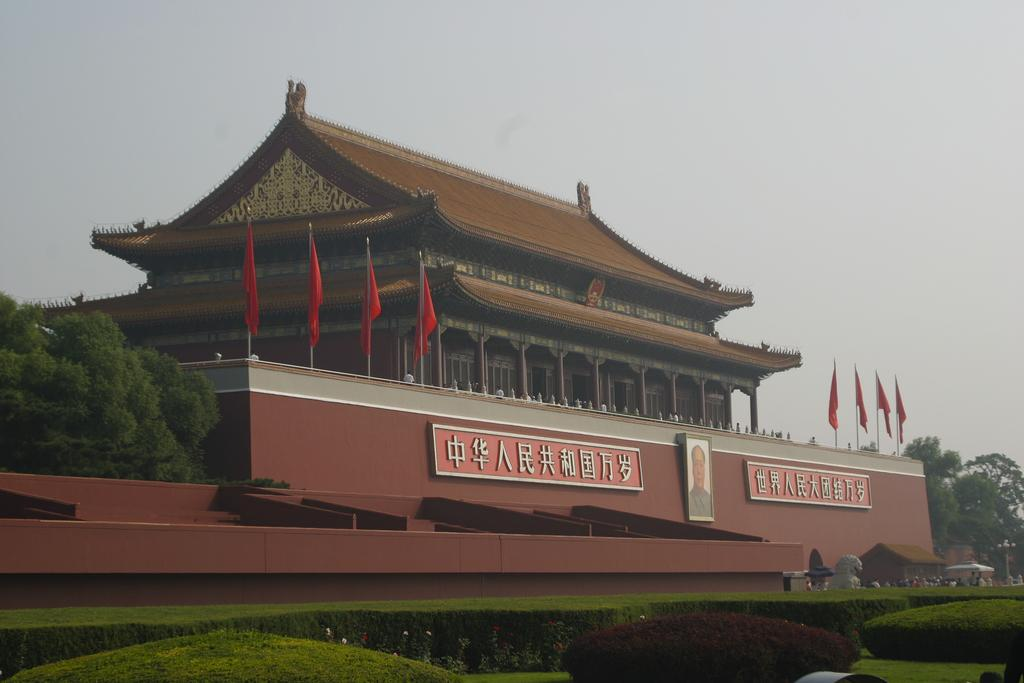What type of structure is visible in the image? There is a building in the image. What can be seen in front of the building? There are trees in front of the building. What type of vegetation is present in the image? There are plants in the image. What is on the wall inside the building? There is a picture on the wall and boards on the wall. What type of cracker is being used as a doorstop in the image? There is no cracker present in the image, nor is there any indication of a doorstop. 